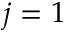<formula> <loc_0><loc_0><loc_500><loc_500>j = 1</formula> 